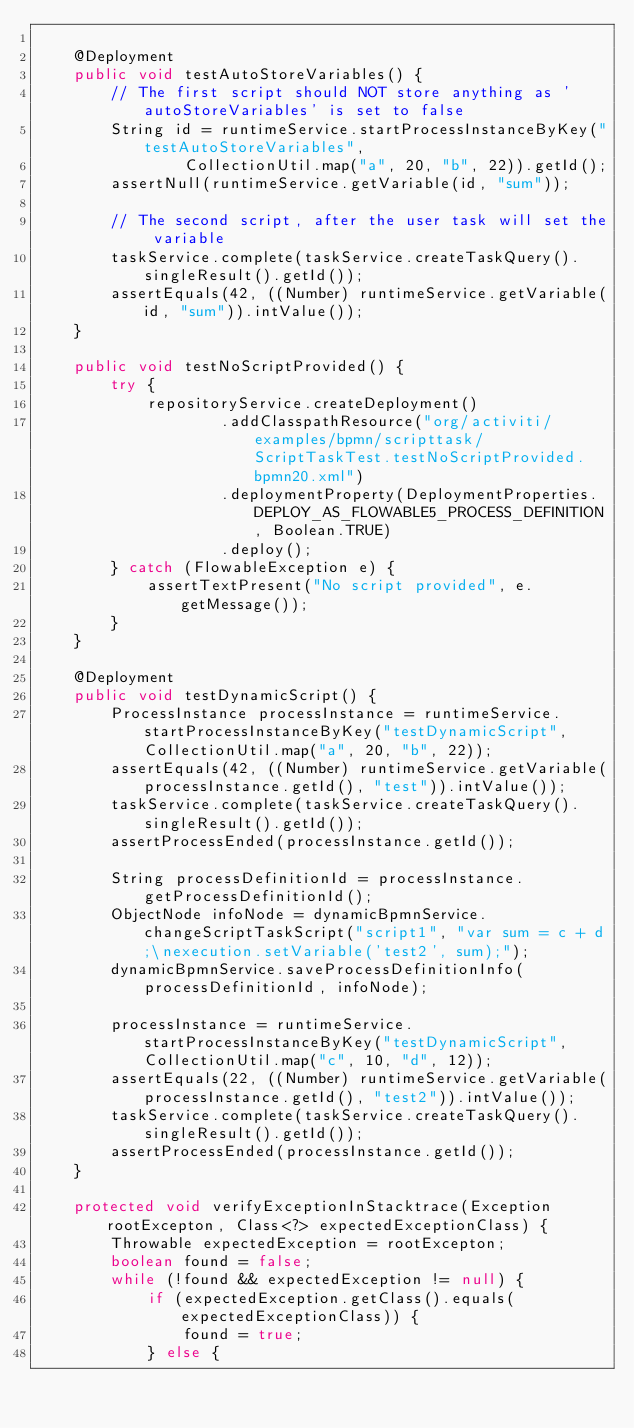Convert code to text. <code><loc_0><loc_0><loc_500><loc_500><_Java_>
    @Deployment
    public void testAutoStoreVariables() {
        // The first script should NOT store anything as 'autoStoreVariables' is set to false
        String id = runtimeService.startProcessInstanceByKey("testAutoStoreVariables",
                CollectionUtil.map("a", 20, "b", 22)).getId();
        assertNull(runtimeService.getVariable(id, "sum"));

        // The second script, after the user task will set the variable
        taskService.complete(taskService.createTaskQuery().singleResult().getId());
        assertEquals(42, ((Number) runtimeService.getVariable(id, "sum")).intValue());
    }

    public void testNoScriptProvided() {
        try {
            repositoryService.createDeployment()
                    .addClasspathResource("org/activiti/examples/bpmn/scripttask/ScriptTaskTest.testNoScriptProvided.bpmn20.xml")
                    .deploymentProperty(DeploymentProperties.DEPLOY_AS_FLOWABLE5_PROCESS_DEFINITION, Boolean.TRUE)
                    .deploy();
        } catch (FlowableException e) {
            assertTextPresent("No script provided", e.getMessage());
        }
    }

    @Deployment
    public void testDynamicScript() {
        ProcessInstance processInstance = runtimeService.startProcessInstanceByKey("testDynamicScript", CollectionUtil.map("a", 20, "b", 22));
        assertEquals(42, ((Number) runtimeService.getVariable(processInstance.getId(), "test")).intValue());
        taskService.complete(taskService.createTaskQuery().singleResult().getId());
        assertProcessEnded(processInstance.getId());

        String processDefinitionId = processInstance.getProcessDefinitionId();
        ObjectNode infoNode = dynamicBpmnService.changeScriptTaskScript("script1", "var sum = c + d;\nexecution.setVariable('test2', sum);");
        dynamicBpmnService.saveProcessDefinitionInfo(processDefinitionId, infoNode);

        processInstance = runtimeService.startProcessInstanceByKey("testDynamicScript", CollectionUtil.map("c", 10, "d", 12));
        assertEquals(22, ((Number) runtimeService.getVariable(processInstance.getId(), "test2")).intValue());
        taskService.complete(taskService.createTaskQuery().singleResult().getId());
        assertProcessEnded(processInstance.getId());
    }

    protected void verifyExceptionInStacktrace(Exception rootExcepton, Class<?> expectedExceptionClass) {
        Throwable expectedException = rootExcepton;
        boolean found = false;
        while (!found && expectedException != null) {
            if (expectedException.getClass().equals(expectedExceptionClass)) {
                found = true;
            } else {</code> 